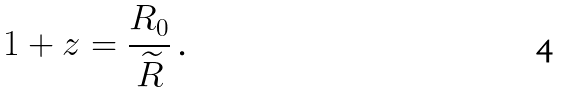<formula> <loc_0><loc_0><loc_500><loc_500>1 + z = \frac { R _ { 0 } } { \widetilde { R } } \text { .}</formula> 